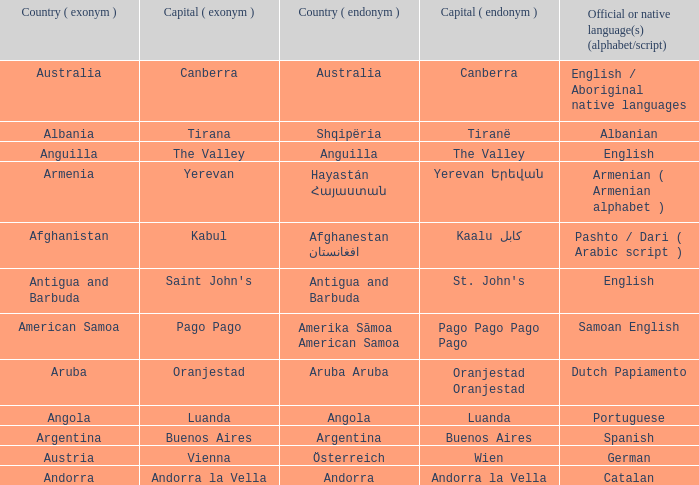What is the English name given to the city of St. John's? Saint John's. 